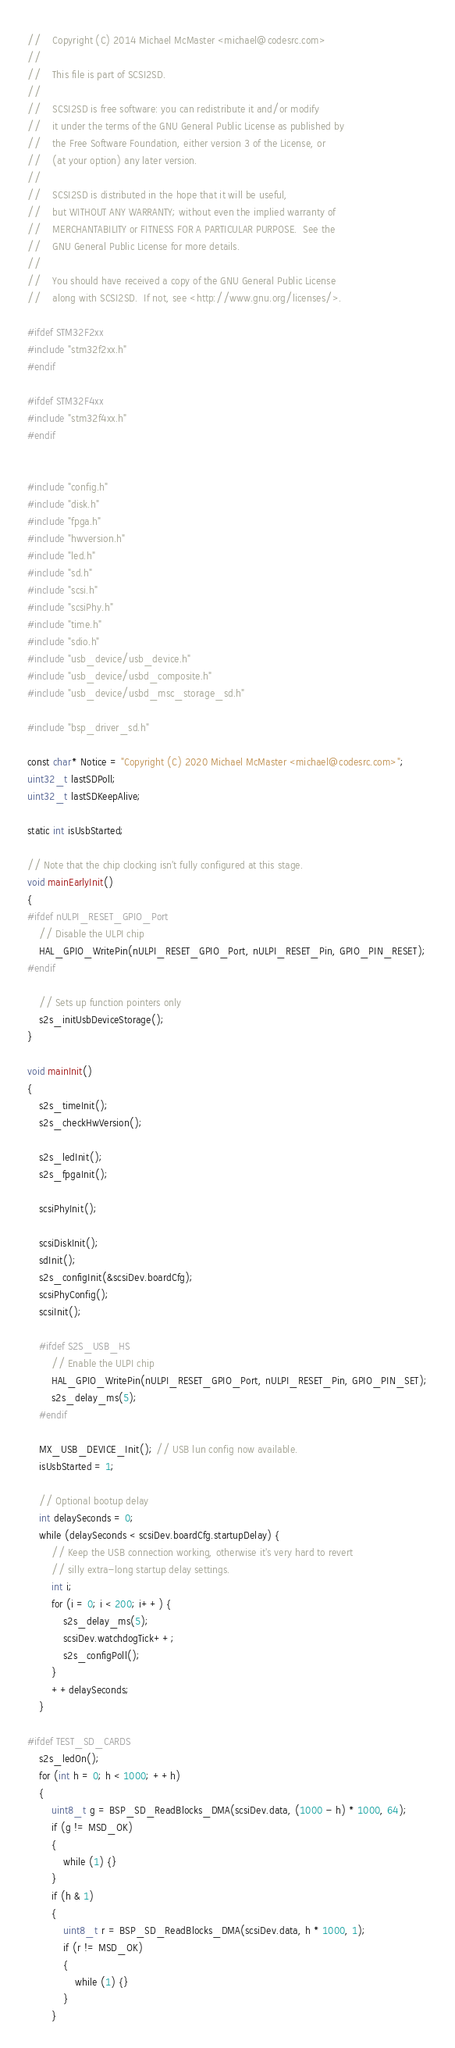<code> <loc_0><loc_0><loc_500><loc_500><_C_>//    Copyright (C) 2014 Michael McMaster <michael@codesrc.com>
//
//    This file is part of SCSI2SD.
//
//    SCSI2SD is free software: you can redistribute it and/or modify
//    it under the terms of the GNU General Public License as published by
//    the Free Software Foundation, either version 3 of the License, or
//    (at your option) any later version.
//
//    SCSI2SD is distributed in the hope that it will be useful,
//    but WITHOUT ANY WARRANTY; without even the implied warranty of
//    MERCHANTABILITY or FITNESS FOR A PARTICULAR PURPOSE.  See the
//    GNU General Public License for more details.
//
//    You should have received a copy of the GNU General Public License
//    along with SCSI2SD.  If not, see <http://www.gnu.org/licenses/>.

#ifdef STM32F2xx
#include "stm32f2xx.h"
#endif

#ifdef STM32F4xx
#include "stm32f4xx.h"
#endif


#include "config.h"
#include "disk.h"
#include "fpga.h"
#include "hwversion.h"
#include "led.h"
#include "sd.h"
#include "scsi.h"
#include "scsiPhy.h"
#include "time.h"
#include "sdio.h"
#include "usb_device/usb_device.h"
#include "usb_device/usbd_composite.h"
#include "usb_device/usbd_msc_storage_sd.h"

#include "bsp_driver_sd.h"

const char* Notice = "Copyright (C) 2020 Michael McMaster <michael@codesrc.com>";
uint32_t lastSDPoll;
uint32_t lastSDKeepAlive;

static int isUsbStarted;

// Note that the chip clocking isn't fully configured at this stage.
void mainEarlyInit()
{
#ifdef nULPI_RESET_GPIO_Port
    // Disable the ULPI chip
    HAL_GPIO_WritePin(nULPI_RESET_GPIO_Port, nULPI_RESET_Pin, GPIO_PIN_RESET);
#endif

    // Sets up function pointers only
    s2s_initUsbDeviceStorage();
}

void mainInit()
{
    s2s_timeInit();
    s2s_checkHwVersion();

    s2s_ledInit();
    s2s_fpgaInit();

    scsiPhyInit();

    scsiDiskInit();
    sdInit();
    s2s_configInit(&scsiDev.boardCfg);
    scsiPhyConfig();
    scsiInit();

    #ifdef S2S_USB_HS
        // Enable the ULPI chip
        HAL_GPIO_WritePin(nULPI_RESET_GPIO_Port, nULPI_RESET_Pin, GPIO_PIN_SET);
        s2s_delay_ms(5);
    #endif

    MX_USB_DEVICE_Init(); // USB lun config now available.
    isUsbStarted = 1;

    // Optional bootup delay
    int delaySeconds = 0;
    while (delaySeconds < scsiDev.boardCfg.startupDelay) {
        // Keep the USB connection working, otherwise it's very hard to revert
        // silly extra-long startup delay settings.
        int i;
        for (i = 0; i < 200; i++) {
            s2s_delay_ms(5);
            scsiDev.watchdogTick++;
            s2s_configPoll();
        }
        ++delaySeconds;
    }

#ifdef TEST_SD_CARDS
    s2s_ledOn();
    for (int h = 0; h < 1000; ++h)
    {
        uint8_t g = BSP_SD_ReadBlocks_DMA(scsiDev.data, (1000 - h) * 1000, 64);
        if (g != MSD_OK)
        {
            while (1) {}
        }
        if (h & 1)
        {
            uint8_t r = BSP_SD_ReadBlocks_DMA(scsiDev.data, h * 1000, 1);
            if (r != MSD_OK)
            {
                while (1) {}
            }
        }</code> 